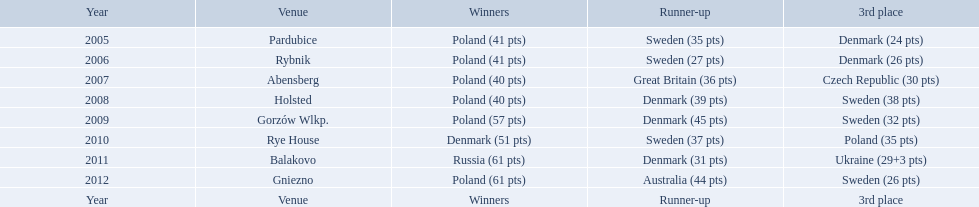Did holland win the 2010 championship? if not who did? Rye House. What did position did holland they rank? 3rd place. In which years did denmark rank in the top 3 in the team speedway junior world championship? 2005, 2006, 2008, 2009, 2010, 2011. In which year did denmark come within 2 points of achieving a higher position in the standings? 2006. What was denmark's position in the year they were just 2 points away from a higher ranking? 3rd place. In which years was denmark among the top 3 teams in the team speedway junior world championship? 2005, 2006, 2008, 2009, 2010, 2011. In what year did denmark fall short of a better ranking by just 2 points? 2006. What was their ranking when they missed the higher position by a mere 2 points? 3rd place. 